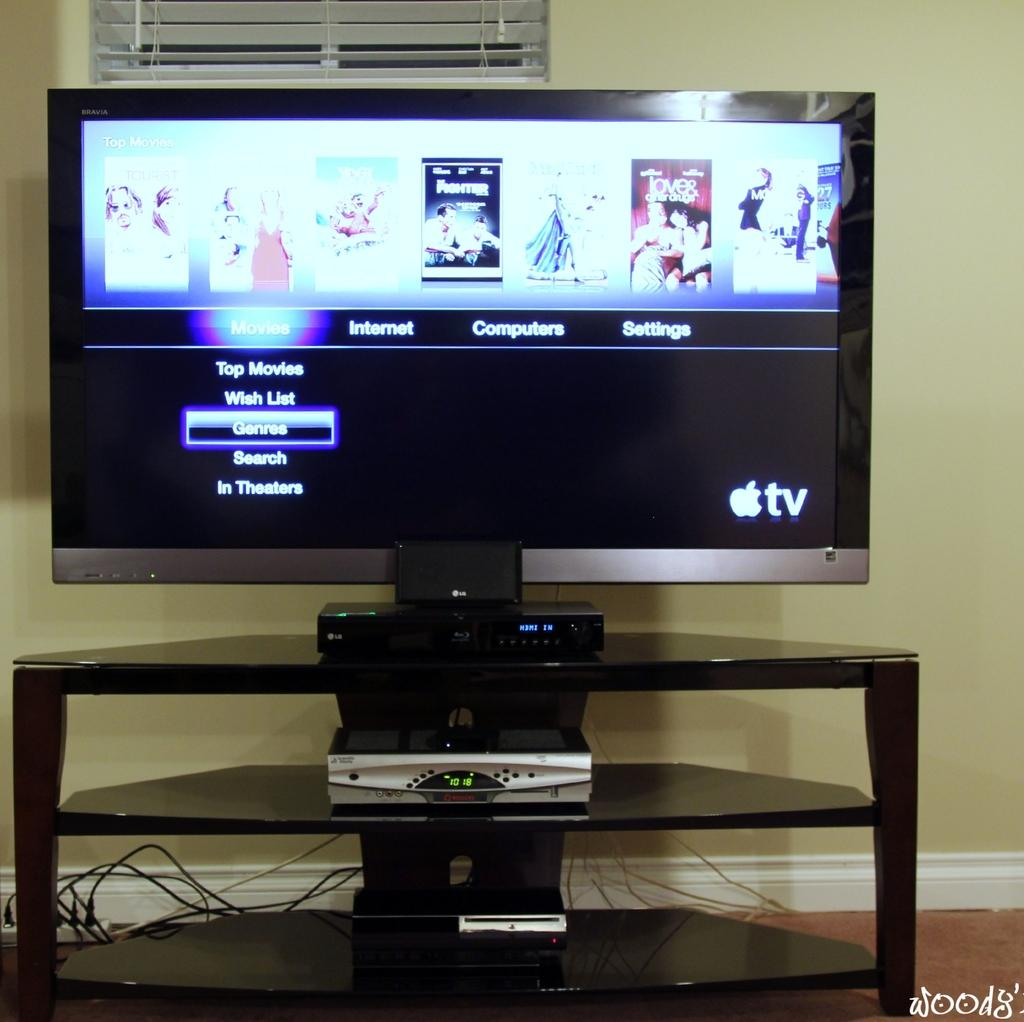<image>
Render a clear and concise summary of the photo. An Apple television on a stand with a screen about internet and computers showing. 